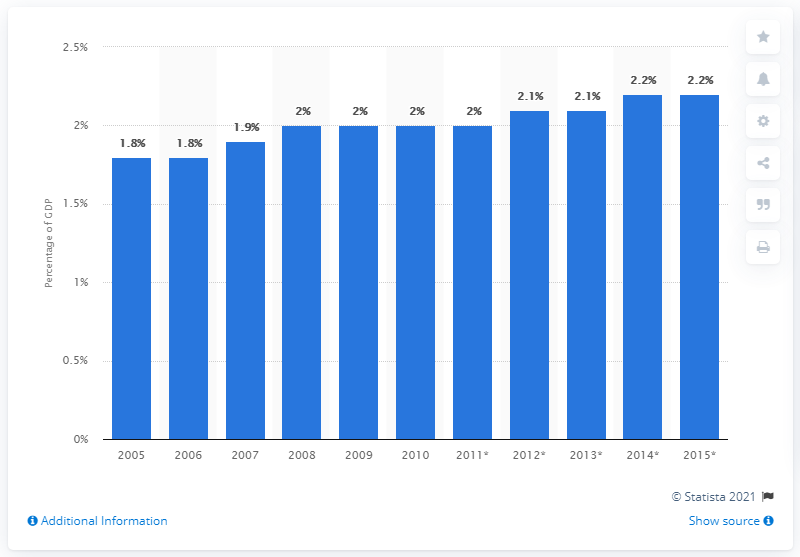Highlight a few significant elements in this photo. In 2012, it is projected that IT services will account for approximately 2.1% of total global GDP. 